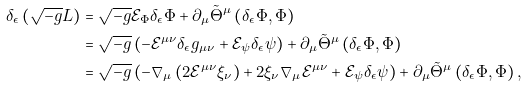Convert formula to latex. <formula><loc_0><loc_0><loc_500><loc_500>\delta _ { \epsilon } \left ( \sqrt { - g } L \right ) & = \sqrt { - g } \mathcal { E } _ { \Phi } \delta _ { \epsilon } \Phi + \partial _ { \mu } \tilde { \Theta } ^ { \mu } \left ( \delta _ { \epsilon } \Phi , \Phi \right ) \\ & = \sqrt { - g } \left ( - \mathcal { E } ^ { \mu \nu } \delta _ { \epsilon } g _ { \mu \nu } + \mathcal { E } _ { \psi } \delta _ { \epsilon } \psi \right ) + \partial _ { \mu } \tilde { \Theta } ^ { \mu } \left ( \delta _ { \epsilon } \Phi , \Phi \right ) \\ & = \sqrt { - g } \left ( - \nabla _ { \mu } \left ( 2 \mathcal { E } ^ { \mu \nu } \xi _ { \nu } \right ) + 2 \xi _ { \nu } \nabla _ { \mu } \mathcal { E } ^ { \mu \nu } + \mathcal { E } _ { \psi } \delta _ { \epsilon } \psi \right ) + \partial _ { \mu } \tilde { \Theta } ^ { \mu } \left ( \delta _ { \epsilon } \Phi , \Phi \right ) ,</formula> 